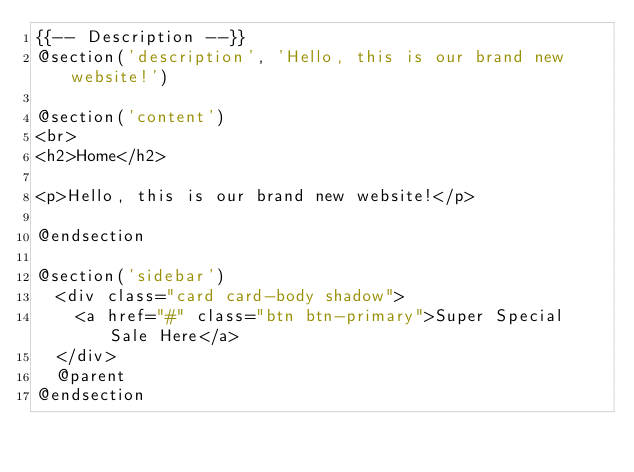<code> <loc_0><loc_0><loc_500><loc_500><_PHP_>{{-- Description --}} 
@section('description', 'Hello, this is our brand new website!')

@section('content')
<br>
<h2>Home</h2>

<p>Hello, this is our brand new website!</p>

@endsection

@section('sidebar')
	<div class="card card-body shadow">
		<a href="#" class="btn btn-primary">Super Special Sale Here</a>
	</div>
	@parent
@endsection
</code> 